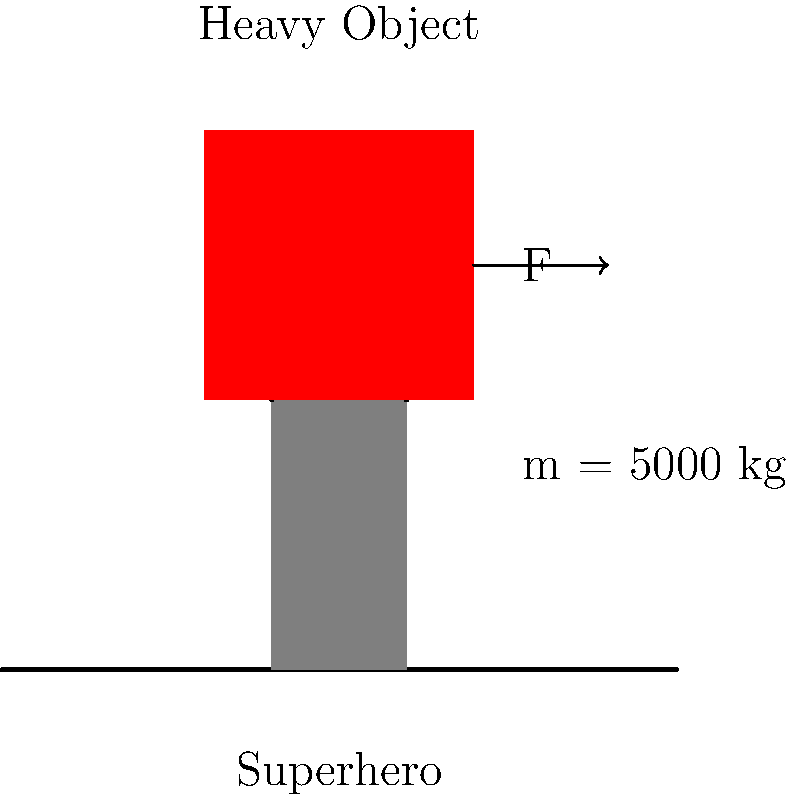In the latest issue of "Super Strength Comics," our hero needs to lift a massive object weighing 5000 kg. Assuming the acceleration due to gravity is $9.8 \text{ m/s}^2$, what minimum force $F$ (in Newtons) must the superhero exert to lift the object off the ground? To solve this problem, we'll use Newton's Second Law of Motion:

1) The force required to lift an object is equal to its weight plus any additional force needed for acceleration. Since we're only concerned with lifting it off the ground, we'll focus on overcoming its weight.

2) Weight is calculated using the formula:
   $W = m \times g$
   Where:
   $W$ is the weight in Newtons (N)
   $m$ is the mass in kilograms (kg)
   $g$ is the acceleration due to gravity in $\text{m/s}^2$

3) Let's substitute our values:
   $W = 5000 \text{ kg} \times 9.8 \text{ m/s}^2$

4) Calculate:
   $W = 49,000 \text{ N}$

5) Therefore, to lift the object, our superhero must exert a force greater than or equal to 49,000 N.

The minimum force required is exactly 49,000 N, as any less would not overcome the object's weight.
Answer: 49,000 N 